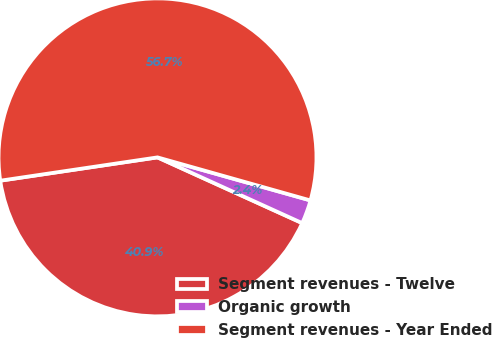<chart> <loc_0><loc_0><loc_500><loc_500><pie_chart><fcel>Segment revenues - Twelve<fcel>Organic growth<fcel>Segment revenues - Year Ended<nl><fcel>40.87%<fcel>2.42%<fcel>56.71%<nl></chart> 